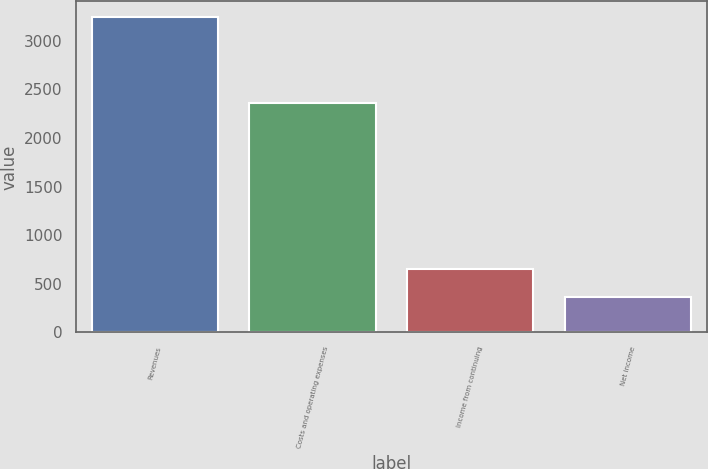Convert chart. <chart><loc_0><loc_0><loc_500><loc_500><bar_chart><fcel>Revenues<fcel>Costs and operating expenses<fcel>Income from continuing<fcel>Net income<nl><fcel>3245<fcel>2364<fcel>653.9<fcel>366<nl></chart> 